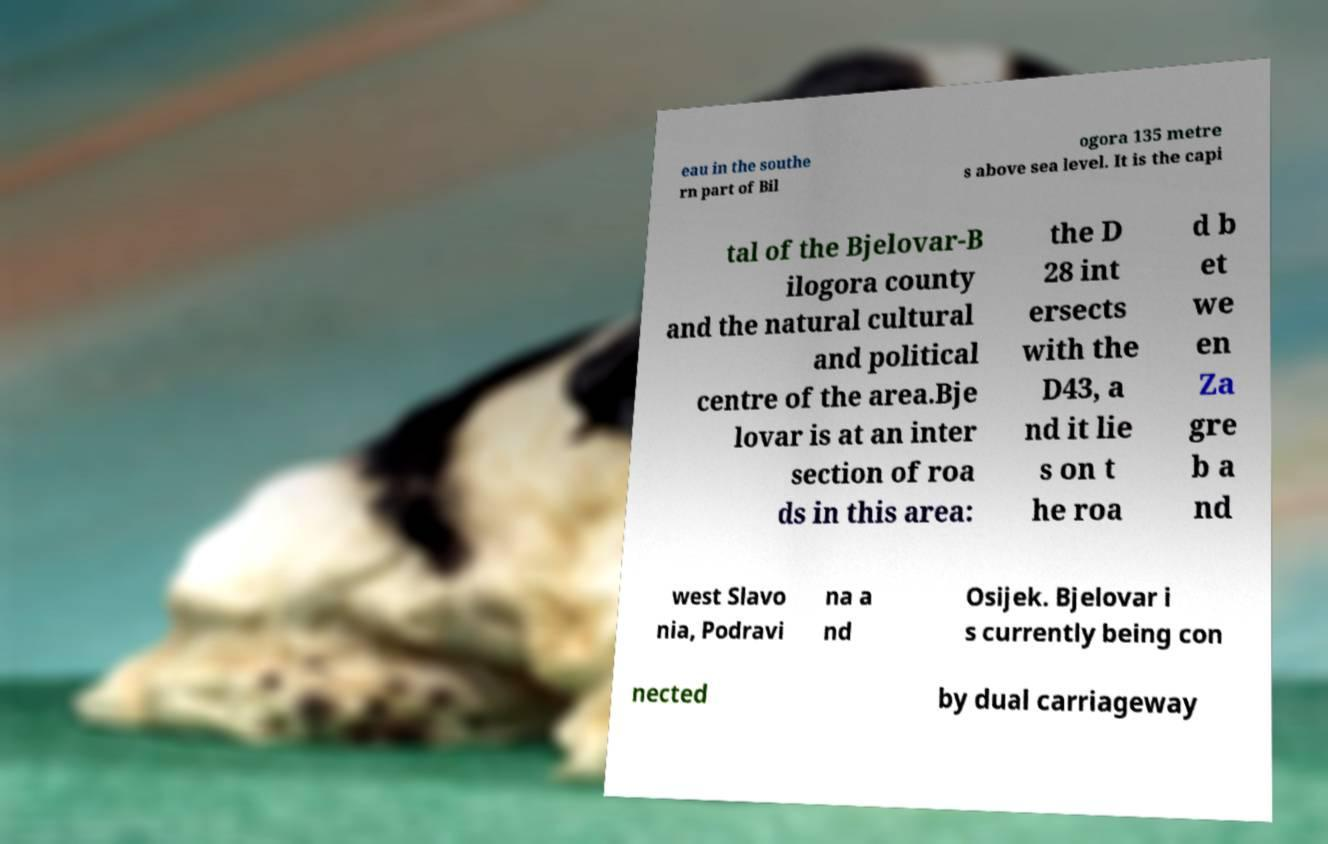I need the written content from this picture converted into text. Can you do that? eau in the southe rn part of Bil ogora 135 metre s above sea level. It is the capi tal of the Bjelovar-B ilogora county and the natural cultural and political centre of the area.Bje lovar is at an inter section of roa ds in this area: the D 28 int ersects with the D43, a nd it lie s on t he roa d b et we en Za gre b a nd west Slavo nia, Podravi na a nd Osijek. Bjelovar i s currently being con nected by dual carriageway 